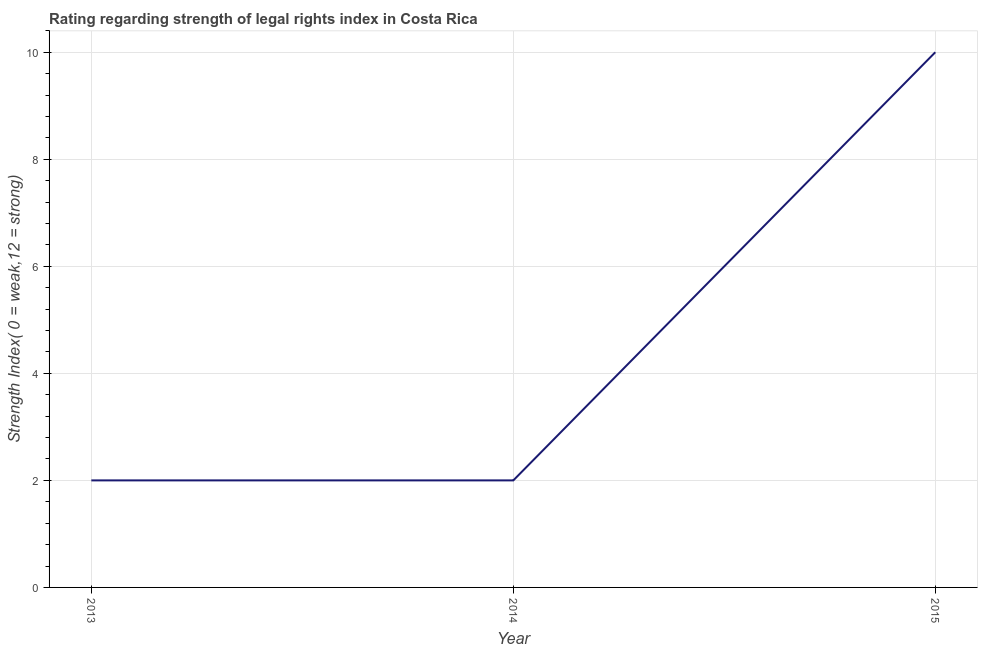What is the strength of legal rights index in 2015?
Provide a short and direct response. 10. Across all years, what is the maximum strength of legal rights index?
Keep it short and to the point. 10. Across all years, what is the minimum strength of legal rights index?
Give a very brief answer. 2. In which year was the strength of legal rights index maximum?
Your answer should be very brief. 2015. In which year was the strength of legal rights index minimum?
Give a very brief answer. 2013. What is the sum of the strength of legal rights index?
Provide a succinct answer. 14. What is the average strength of legal rights index per year?
Keep it short and to the point. 4.67. What is the median strength of legal rights index?
Your response must be concise. 2. What is the ratio of the strength of legal rights index in 2014 to that in 2015?
Provide a succinct answer. 0.2. Is the strength of legal rights index in 2014 less than that in 2015?
Give a very brief answer. Yes. What is the difference between the highest and the second highest strength of legal rights index?
Provide a short and direct response. 8. Is the sum of the strength of legal rights index in 2013 and 2014 greater than the maximum strength of legal rights index across all years?
Offer a very short reply. No. What is the difference between the highest and the lowest strength of legal rights index?
Make the answer very short. 8. In how many years, is the strength of legal rights index greater than the average strength of legal rights index taken over all years?
Keep it short and to the point. 1. Does the strength of legal rights index monotonically increase over the years?
Provide a succinct answer. No. What is the difference between two consecutive major ticks on the Y-axis?
Make the answer very short. 2. Are the values on the major ticks of Y-axis written in scientific E-notation?
Keep it short and to the point. No. Does the graph contain any zero values?
Provide a succinct answer. No. What is the title of the graph?
Offer a very short reply. Rating regarding strength of legal rights index in Costa Rica. What is the label or title of the X-axis?
Make the answer very short. Year. What is the label or title of the Y-axis?
Your response must be concise. Strength Index( 0 = weak,12 = strong). What is the Strength Index( 0 = weak,12 = strong) in 2013?
Offer a very short reply. 2. What is the Strength Index( 0 = weak,12 = strong) in 2015?
Make the answer very short. 10. 